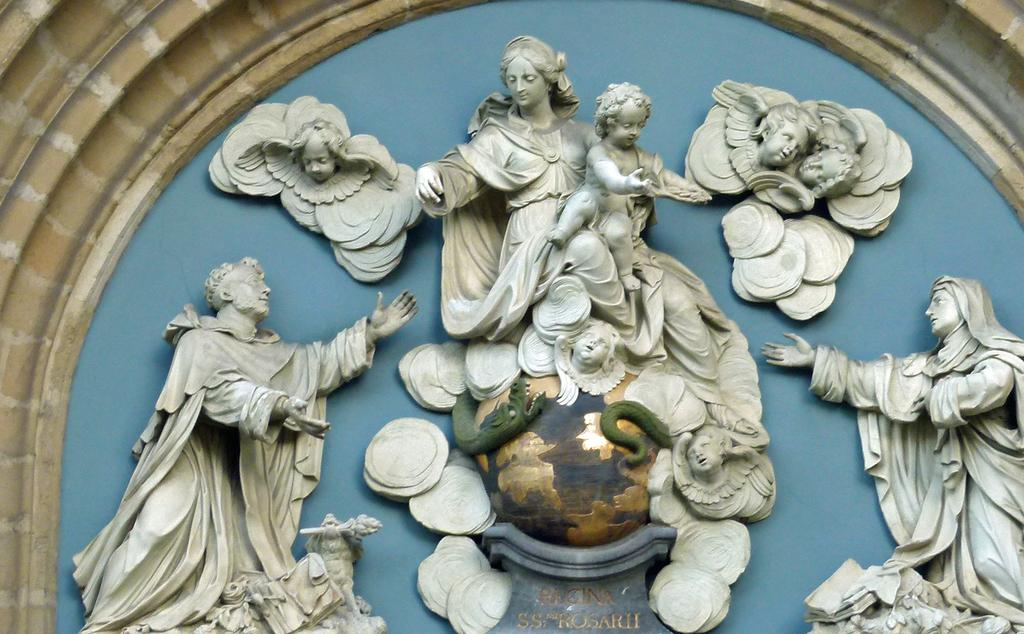What can be seen in the image? There are statues in the image. What is the color of the statues? The statues are white in color. What is the color of the background in the image? The background of the image is blue. What is the color of the wall in the background? The wall in the background is brown and white in color. What is the caption written on the statues in the image? There is no caption written on the statues in the image; they are statues and do not have text. 